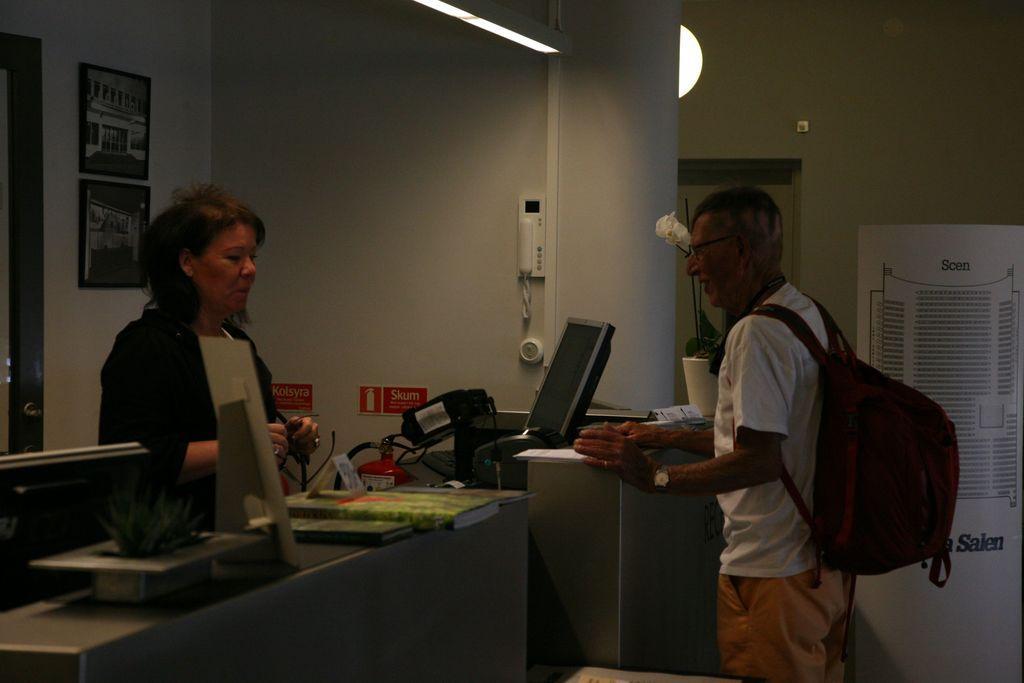In one or two sentences, can you explain what this image depicts? In this image I see a woman and a man, who are standing. I can also see that this man is carrying a bag. Over here I see a screen and many things on the table. In the background I see the 2 photo frames, a telephone and the wall. 